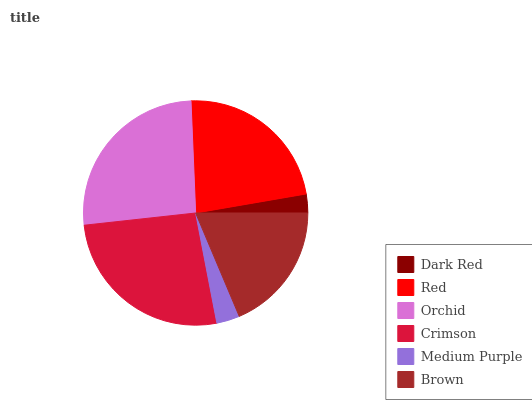Is Dark Red the minimum?
Answer yes or no. Yes. Is Crimson the maximum?
Answer yes or no. Yes. Is Red the minimum?
Answer yes or no. No. Is Red the maximum?
Answer yes or no. No. Is Red greater than Dark Red?
Answer yes or no. Yes. Is Dark Red less than Red?
Answer yes or no. Yes. Is Dark Red greater than Red?
Answer yes or no. No. Is Red less than Dark Red?
Answer yes or no. No. Is Red the high median?
Answer yes or no. Yes. Is Brown the low median?
Answer yes or no. Yes. Is Dark Red the high median?
Answer yes or no. No. Is Orchid the low median?
Answer yes or no. No. 